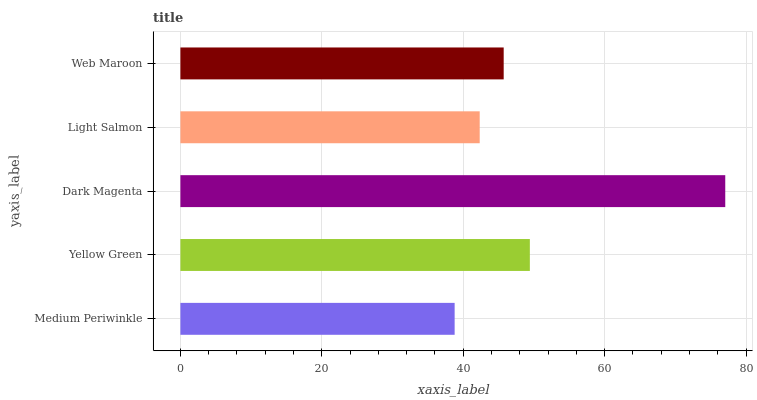Is Medium Periwinkle the minimum?
Answer yes or no. Yes. Is Dark Magenta the maximum?
Answer yes or no. Yes. Is Yellow Green the minimum?
Answer yes or no. No. Is Yellow Green the maximum?
Answer yes or no. No. Is Yellow Green greater than Medium Periwinkle?
Answer yes or no. Yes. Is Medium Periwinkle less than Yellow Green?
Answer yes or no. Yes. Is Medium Periwinkle greater than Yellow Green?
Answer yes or no. No. Is Yellow Green less than Medium Periwinkle?
Answer yes or no. No. Is Web Maroon the high median?
Answer yes or no. Yes. Is Web Maroon the low median?
Answer yes or no. Yes. Is Light Salmon the high median?
Answer yes or no. No. Is Yellow Green the low median?
Answer yes or no. No. 